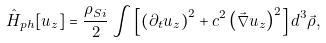<formula> <loc_0><loc_0><loc_500><loc_500>\hat { H } _ { p h } [ u _ { z } ] = \frac { \rho _ { S i } } { 2 } \int \left [ \left ( \partial _ { t } u _ { z } \right ) ^ { 2 } + c ^ { 2 } \left ( \vec { \nabla } u _ { z } \right ) ^ { 2 } \right ] d ^ { 3 } \vec { \rho } ,</formula> 